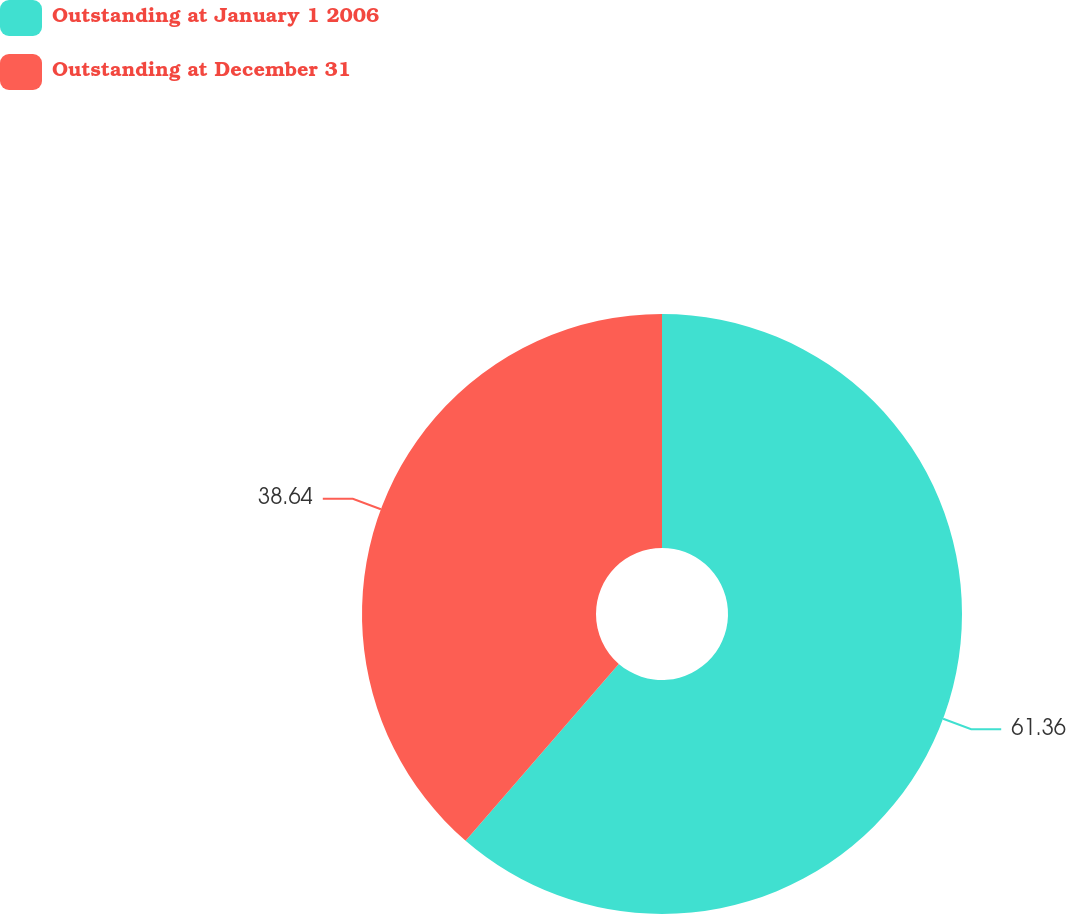Convert chart. <chart><loc_0><loc_0><loc_500><loc_500><pie_chart><fcel>Outstanding at January 1 2006<fcel>Outstanding at December 31<nl><fcel>61.36%<fcel>38.64%<nl></chart> 